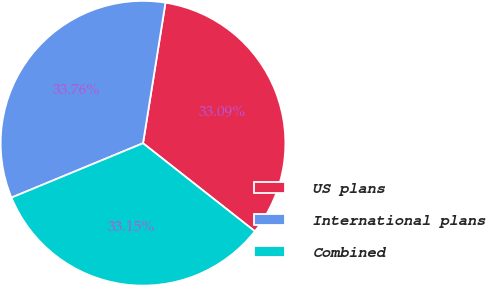<chart> <loc_0><loc_0><loc_500><loc_500><pie_chart><fcel>US plans<fcel>International plans<fcel>Combined<nl><fcel>33.09%<fcel>33.76%<fcel>33.15%<nl></chart> 